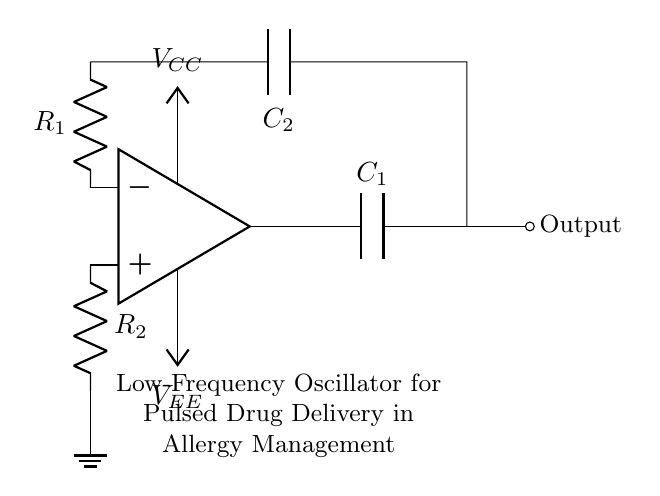What is the function of the op-amp in this circuit? The op-amp functions as a voltage amplifier, which is essential for generating oscillations. It takes the input signals and amplifies them to create a larger output signal, crucial for controlling the pulsed drug delivery.
Answer: voltage amplifier What are the values of the resistors in the circuit? The resistor values are denoted as R1 and R2, which are typically determined by the design specifications or application requirements for the oscillator. Specific numerical values are not given in the diagram, but they are essential for setting the frequency of oscillation.
Answer: R1 and R2 How many capacitors are present in the circuit? There are two capacitors, C1 and C2, which are used to create the timing elements necessary for the oscillator's frequency.
Answer: two What is the purpose of the capacitors C1 and C2? C1 and C2 are used to set the timing characteristics of the oscillator, which determine the frequency of the output pulse necessary for controlling the drug delivery. Their capacitance values directly affect the oscillation period.
Answer: timing Which nodes represent the power supply in the circuit? The power supply nodes are represented by Vcc and Vee, which provide the necessary voltage levels for the op-amp to function correctly. These define the upper and lower limits of the op-amp's output.
Answer: Vcc and Vee How does changing the values of R1 and R2 affect the oscillator frequency? Changing the values of R1 and R2 will alter the time constant of the RC network formed with C1 and C2, which affects the charging and discharging rates of the capacitors. This, in turn, modifies the frequency of oscillation according to the formulas derived from the RC time constants.
Answer: alters frequency 